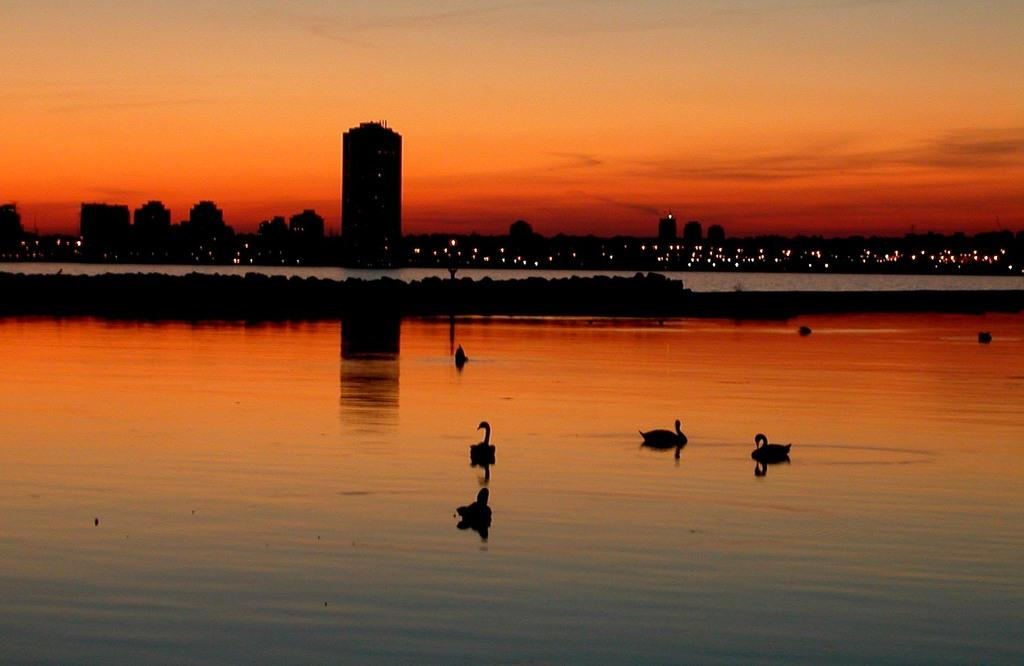What type of animals can be seen in the image? There are ducks in the water in the image. What can be seen in the background of the image? There are buildings and lights visible in the background, as well as the sky. How many letters did the ducks lose in the image? There are no letters present in the image, and ducks do not have the ability to lose letters. 